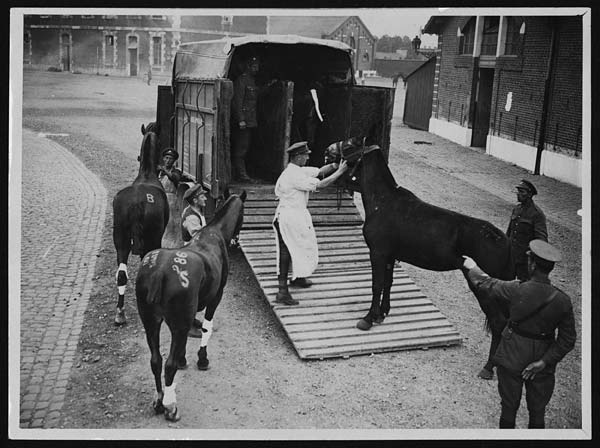Describe the objects in this image and their specific colors. I can see truck in black, darkgray, gray, and lightgray tones, horse in black, darkgray, gray, and lightgray tones, horse in black, gray, darkgray, and lightgray tones, people in black, gray, and lightgray tones, and people in black, lightgray, darkgray, and gray tones in this image. 